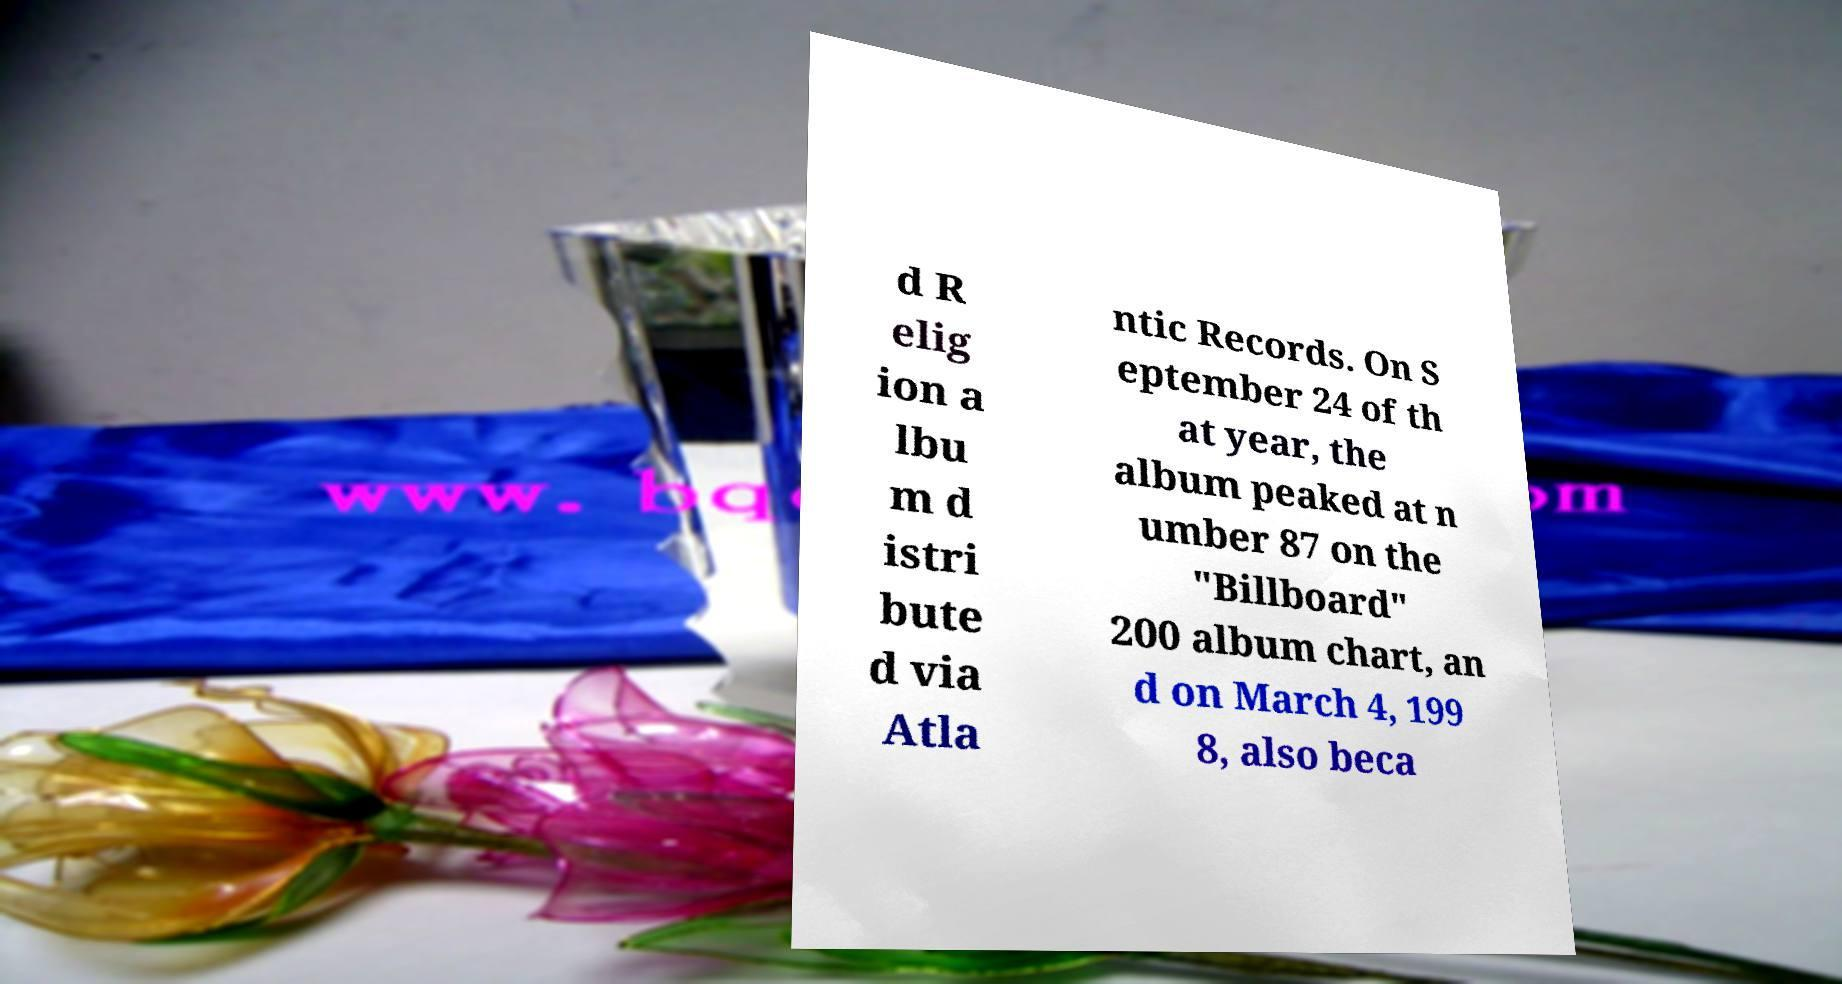Please read and relay the text visible in this image. What does it say? d R elig ion a lbu m d istri bute d via Atla ntic Records. On S eptember 24 of th at year, the album peaked at n umber 87 on the "Billboard" 200 album chart, an d on March 4, 199 8, also beca 